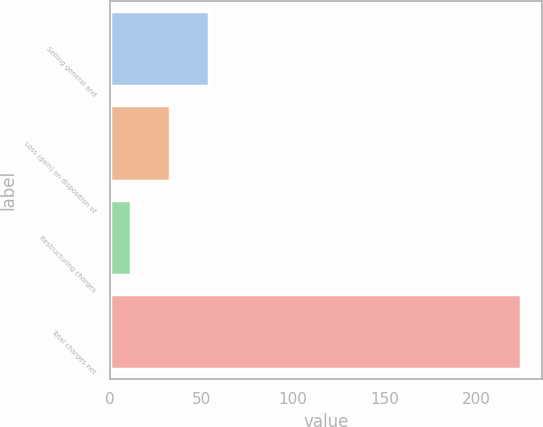<chart> <loc_0><loc_0><loc_500><loc_500><bar_chart><fcel>Selling general and<fcel>Loss (gain) on disposition of<fcel>Restructuring charges<fcel>Total charges net<nl><fcel>54.04<fcel>32.72<fcel>11.4<fcel>224.6<nl></chart> 